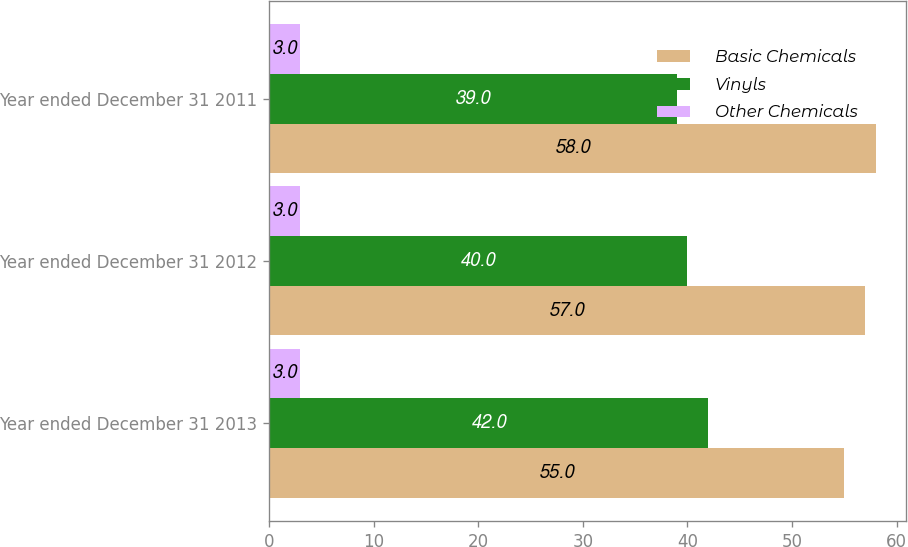Convert chart. <chart><loc_0><loc_0><loc_500><loc_500><stacked_bar_chart><ecel><fcel>Year ended December 31 2013<fcel>Year ended December 31 2012<fcel>Year ended December 31 2011<nl><fcel>Basic Chemicals<fcel>55<fcel>57<fcel>58<nl><fcel>Vinyls<fcel>42<fcel>40<fcel>39<nl><fcel>Other Chemicals<fcel>3<fcel>3<fcel>3<nl></chart> 